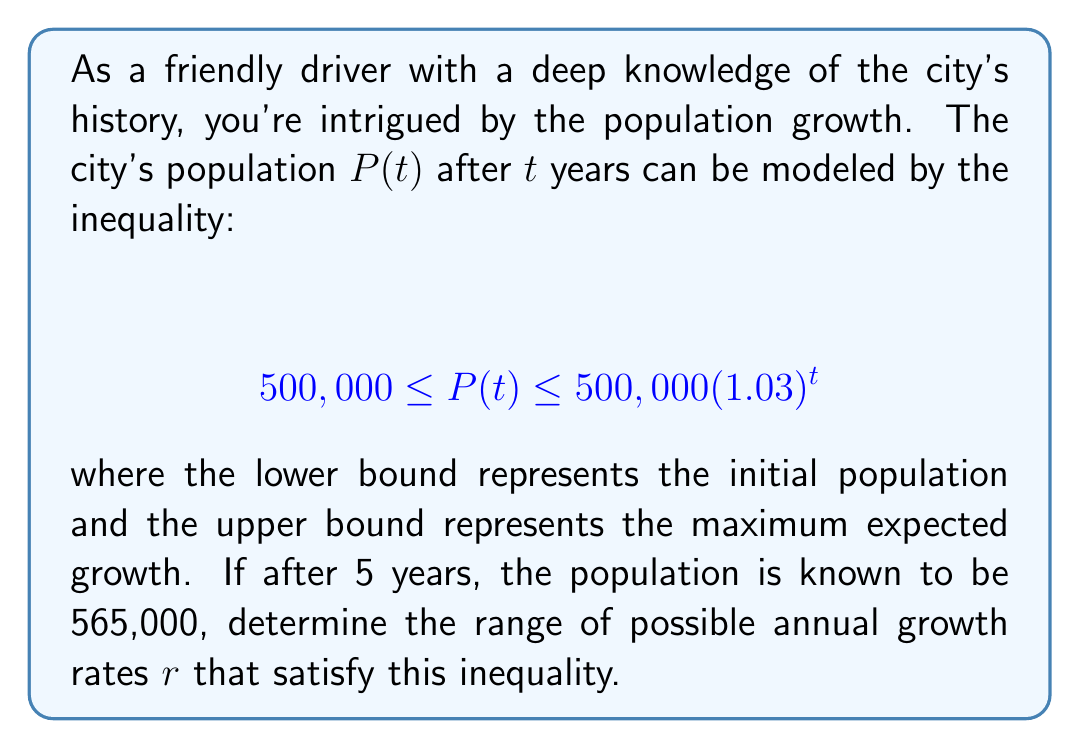Give your solution to this math problem. Let's approach this step-by-step:

1) The general form of exponential population growth is $P(t) = P_0(1+r)^t$, where $P_0$ is the initial population and $r$ is the annual growth rate.

2) We're given that after 5 years, $P(5) = 565,000$. We can set up the inequality:

   $$ 500,000(1+r)^5 \leq 565,000 \leq 500,000(1.03)^5 $$

3) Let's solve the left side of the inequality first:
   
   $500,000(1+r)^5 \leq 565,000$
   $(1+r)^5 \leq \frac{565,000}{500,000} = 1.13$
   $1+r \leq 1.13^{\frac{1}{5}} \approx 1.0247$
   $r \leq 0.0247$

4) Now, let's solve the right side:
   
   $565,000 \leq 500,000(1.03)^5$
   $1.13 \leq (1.03)^5 \approx 1.1593$

   This inequality is always true, so it doesn't give us a lower bound on $r$.

5) However, we know that the population has increased, so $r$ must be positive.

Therefore, the range of possible annual growth rates is:

$$ 0 < r \leq 0.0247 $$

This means the annual growth rate is between 0% and 2.47%.
Answer: $0 < r \leq 0.0247$ or $(0\%, 2.47\%]$ 